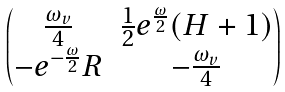<formula> <loc_0><loc_0><loc_500><loc_500>\begin{pmatrix} \frac { \omega _ { v } } { 4 } & \frac { 1 } { 2 } e ^ { \frac { \omega } { 2 } } ( H + 1 ) \\ - e ^ { - \frac { \omega } { 2 } } R & - \frac { \omega _ { v } } { 4 } \end{pmatrix}</formula> 